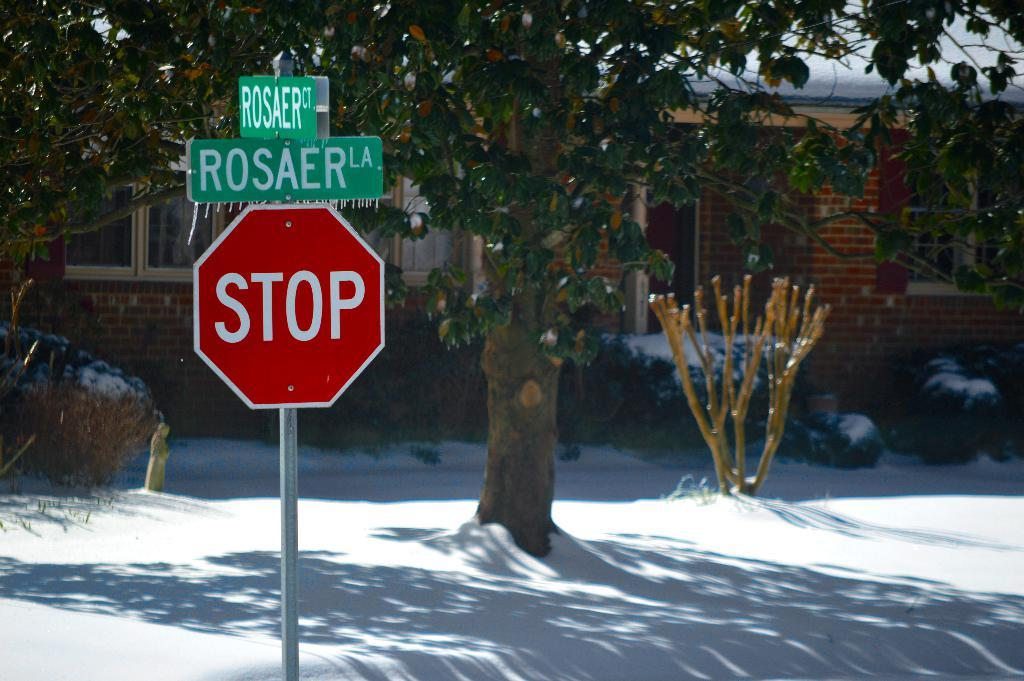<image>
Present a compact description of the photo's key features. A stop sign is below a street sign for Rosaer LA. 